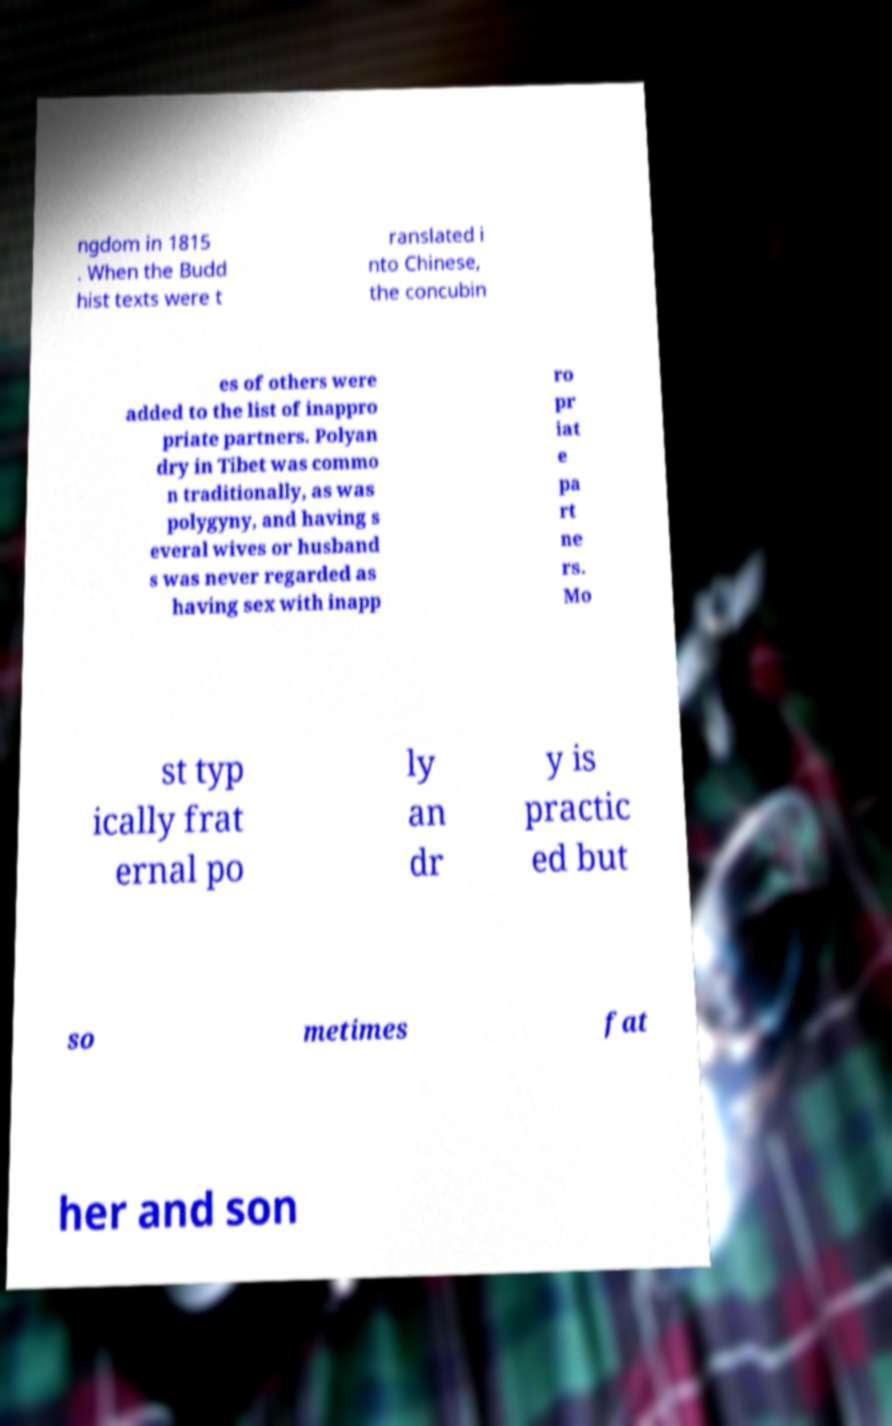Please read and relay the text visible in this image. What does it say? ngdom in 1815 . When the Budd hist texts were t ranslated i nto Chinese, the concubin es of others were added to the list of inappro priate partners. Polyan dry in Tibet was commo n traditionally, as was polygyny, and having s everal wives or husband s was never regarded as having sex with inapp ro pr iat e pa rt ne rs. Mo st typ ically frat ernal po ly an dr y is practic ed but so metimes fat her and son 